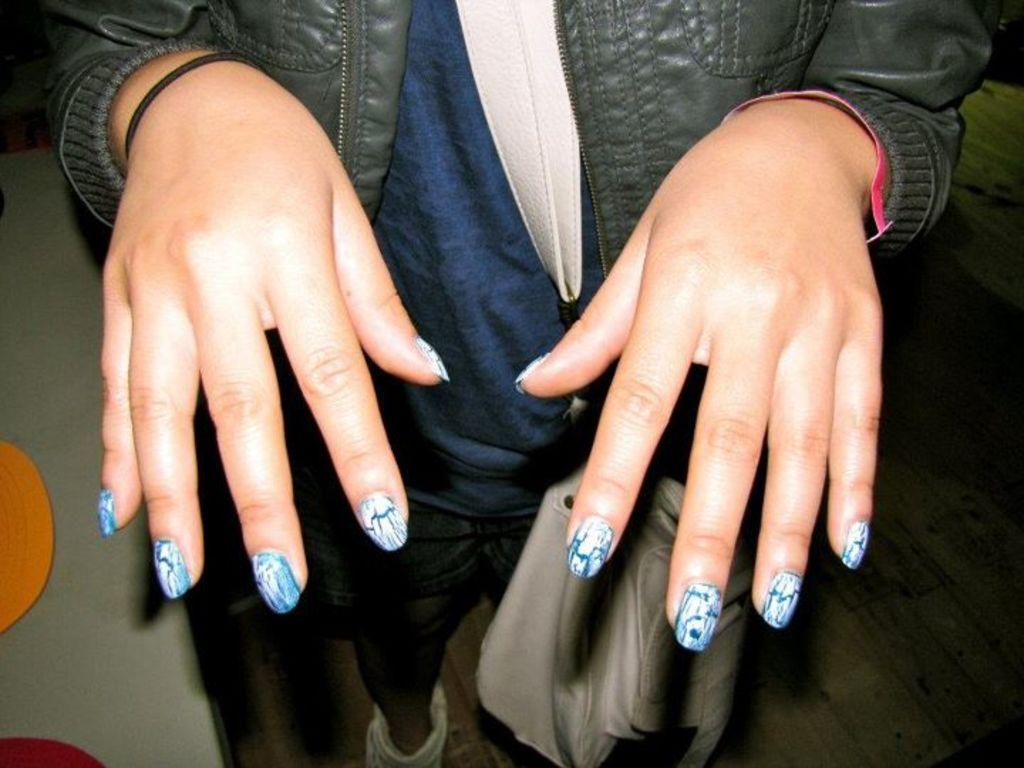What is the main subject of the image? There is a person in the image. What is the person holding or carrying in the image? The person is carrying a bag. Can you describe the person's position or appearance in the image? The person is partially cut off or "truncated" in the image. Can you see any boats in the image? There are no boats present in the image. What type of milk is the person drinking in the image? There is no milk or drinking activity depicted in the image. 